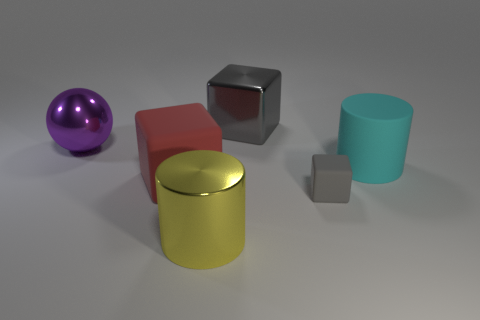How many gray blocks must be subtracted to get 1 gray blocks? 1 Add 4 gray cubes. How many objects exist? 10 Subtract all cylinders. How many objects are left? 4 Subtract 1 cylinders. How many cylinders are left? 1 Subtract all cyan cylinders. Subtract all blue balls. How many cylinders are left? 1 Subtract all green spheres. How many red blocks are left? 1 Subtract all red rubber things. Subtract all big yellow metallic cylinders. How many objects are left? 4 Add 1 gray rubber cubes. How many gray rubber cubes are left? 2 Add 3 large metal cylinders. How many large metal cylinders exist? 4 Subtract all yellow cylinders. How many cylinders are left? 1 